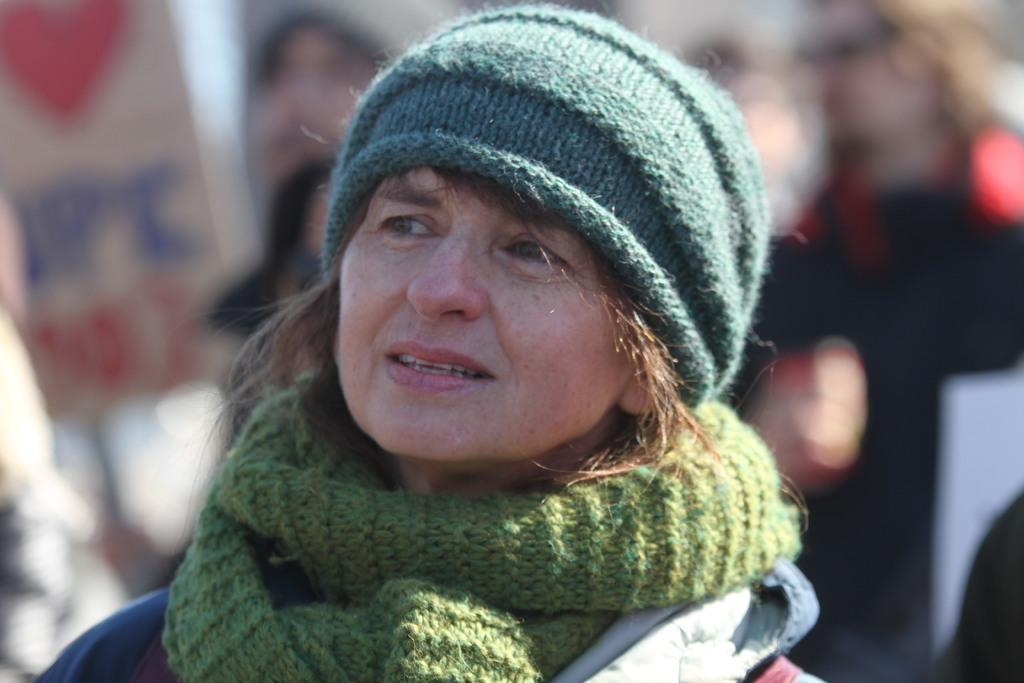Who is the main subject in the image? There is a woman in the image. What is the woman wearing on her head? The woman is wearing a blue hat. What is the woman wearing around her neck? The woman is wearing a green scarf. How would you describe the background of the image? The background of the image is blurry. Can you see any other people in the image? Yes, there are people visible in the background. Is the woman in the image driving a car? There is no indication in the image that the woman is driving a car. Is the woman in the image sleeping? There is no indication in the image that the woman is sleeping. 